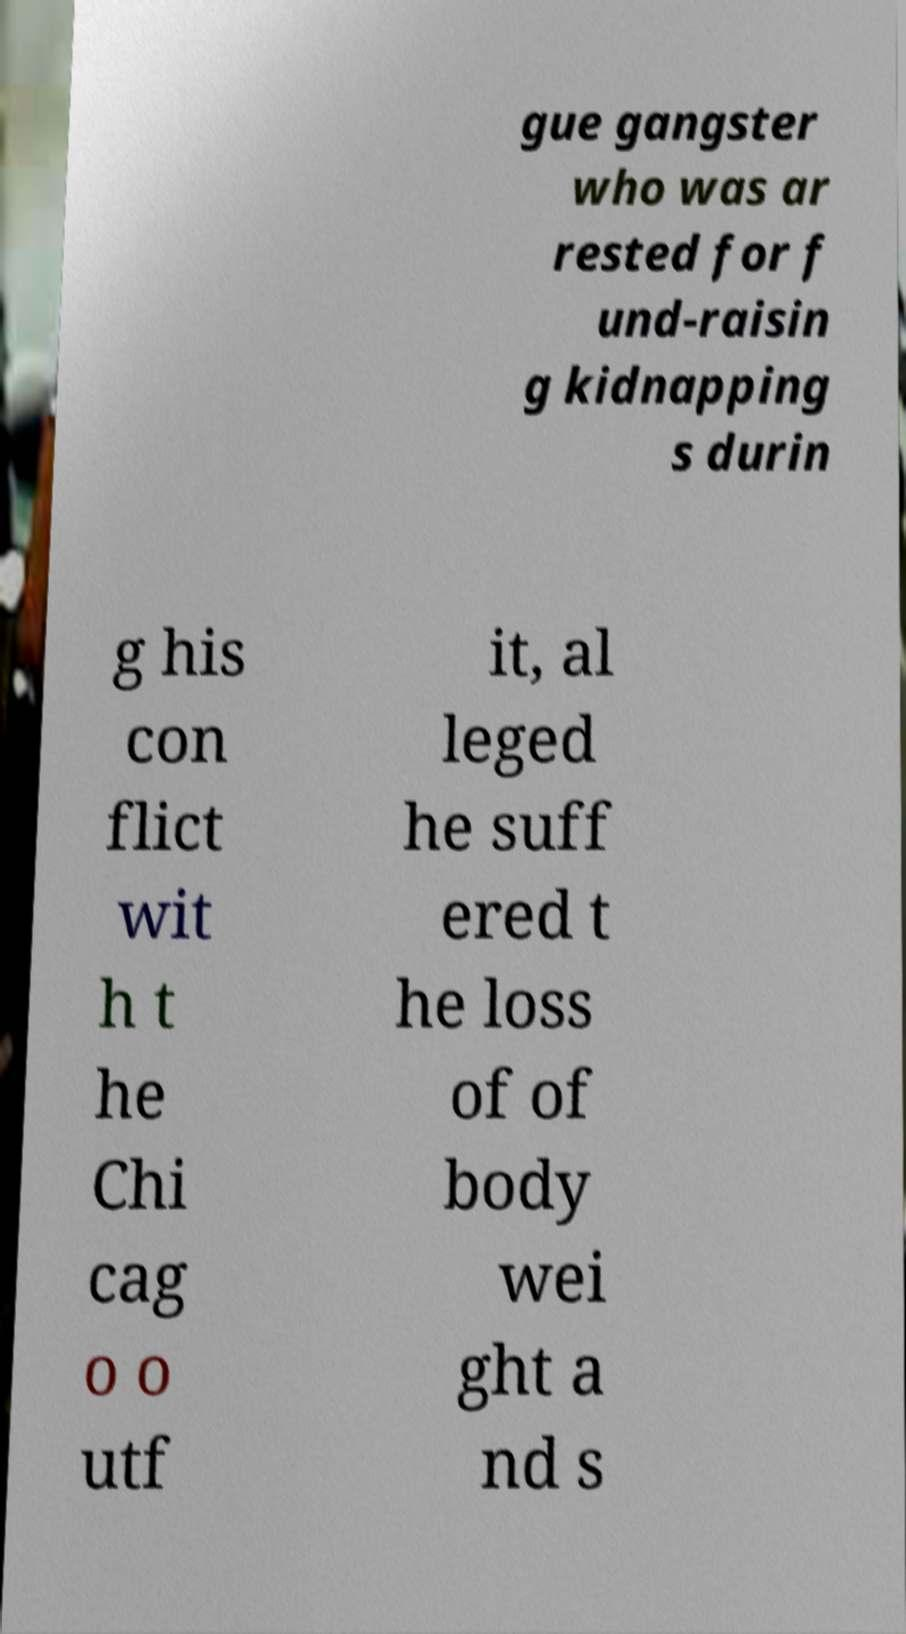Could you extract and type out the text from this image? gue gangster who was ar rested for f und-raisin g kidnapping s durin g his con flict wit h t he Chi cag o o utf it, al leged he suff ered t he loss of of body wei ght a nd s 